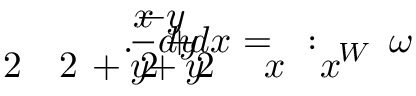<formula> <loc_0><loc_0><loc_500><loc_500>\, \omega \, _ { W } \, \colon \, = \, \frac { \, - y } { x \, ^ { \, } \, 2 \, + y \, ^ { \, } \, 2 } d x \, + \, \frac { x } { x \, ^ { \, } \, 2 \, + y \, ^ { \, } \, 2 } d y \, . \,</formula> 